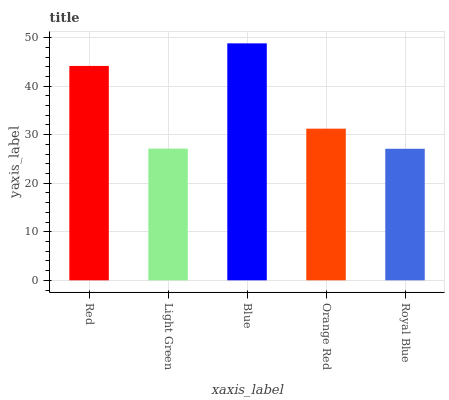Is Royal Blue the minimum?
Answer yes or no. Yes. Is Blue the maximum?
Answer yes or no. Yes. Is Light Green the minimum?
Answer yes or no. No. Is Light Green the maximum?
Answer yes or no. No. Is Red greater than Light Green?
Answer yes or no. Yes. Is Light Green less than Red?
Answer yes or no. Yes. Is Light Green greater than Red?
Answer yes or no. No. Is Red less than Light Green?
Answer yes or no. No. Is Orange Red the high median?
Answer yes or no. Yes. Is Orange Red the low median?
Answer yes or no. Yes. Is Light Green the high median?
Answer yes or no. No. Is Royal Blue the low median?
Answer yes or no. No. 